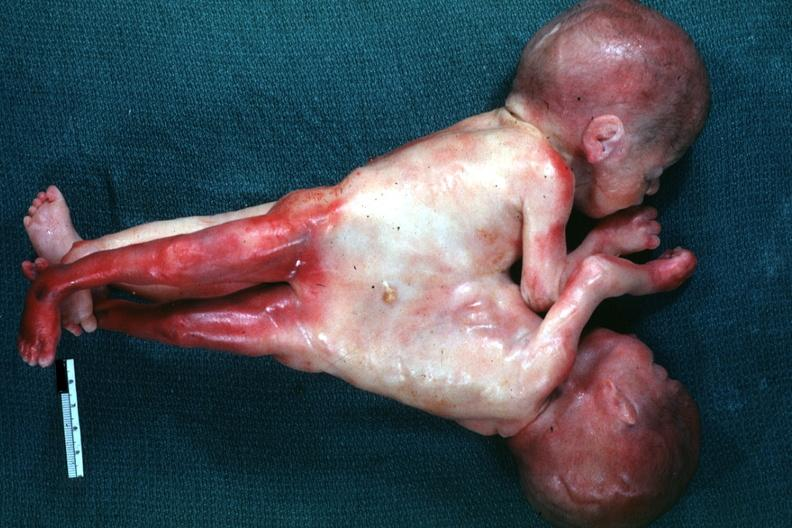what is present?
Answer the question using a single word or phrase. Siamese twins 